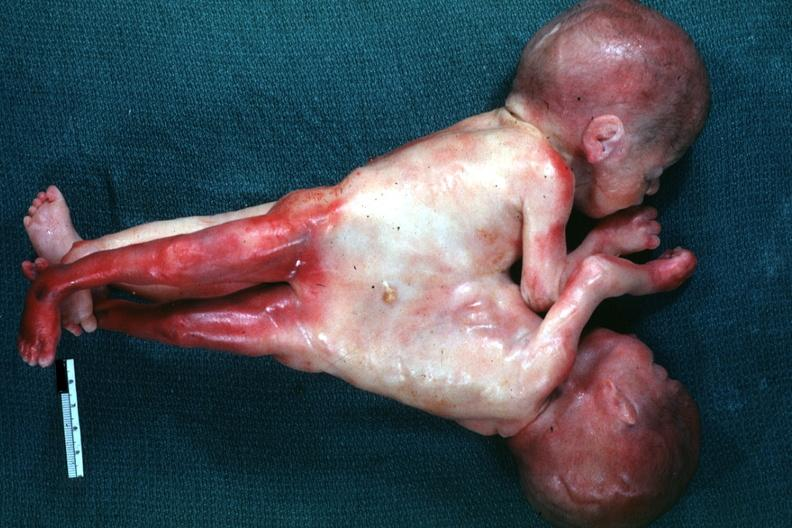what is present?
Answer the question using a single word or phrase. Siamese twins 